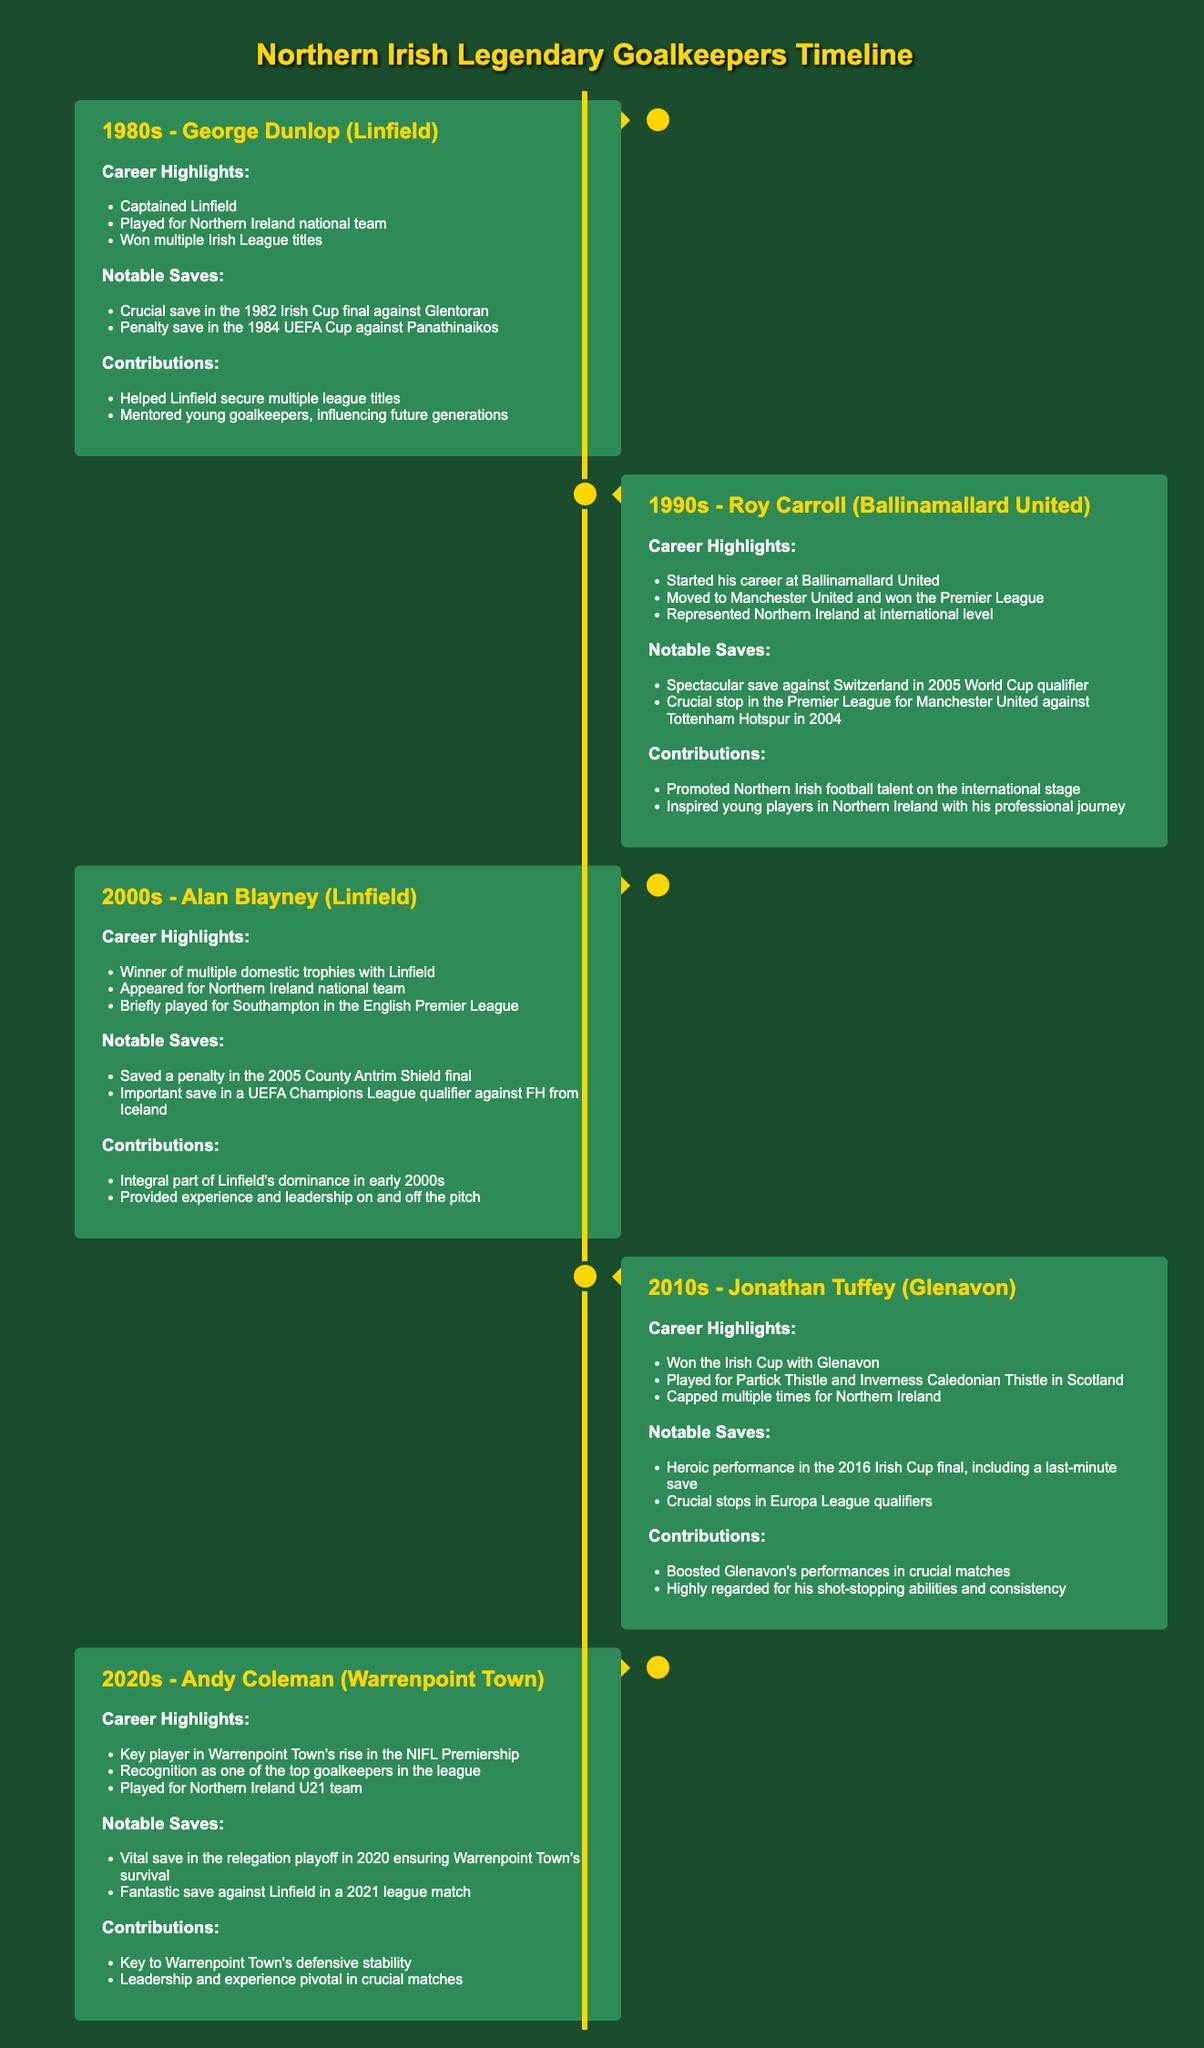What decade did George Dunlop play in? George Dunlop is featured in the timeline under the 1980s section.
Answer: 1980s Which club did Roy Carroll start his career with? The timeline specifies that Roy Carroll started his career at Ballinamallard United.
Answer: Ballinamallard United What significant trophy did Jonathan Tuffey win with Glenavon? The timeline highlights that Jonathan Tuffey won the Irish Cup with Glenavon.
Answer: Irish Cup How many penalty saves did Alan Blayney make in notable saves mentioned? The notable saves section for Alan Blayney lists two specific penalty saves.
Answer: Two Who is recognized as one of the top goalkeepers in the NIFL Premiership? The timeline indicates that Andy Coleman is recognized as one of the top goalkeepers in the league.
Answer: Andy Coleman What was a key contribution of George Dunlop to Linfield? The timeline mentions that George Dunlop helped Linfield secure multiple league titles.
Answer: Secured multiple league titles Which goalkeeper played for the Northern Ireland U21 team? The document mentions that Andy Coleman played for the Northern Ireland U21 team.
Answer: Andy Coleman In which year did Roy Carroll perform a spectacular save against Switzerland? The timeline states that Roy Carroll made the save in a 2005 World Cup qualifier.
Answer: 2005 What unique characteristic is highlighted about the timeline format of the document? The unique characteristic of the timeline format is the chronological arrangement of goalkeeper achievements through the decades.
Answer: Chronological arrangement 